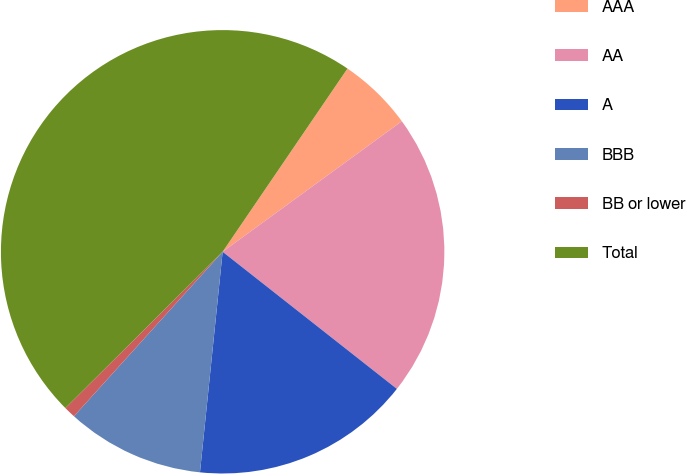Convert chart to OTSL. <chart><loc_0><loc_0><loc_500><loc_500><pie_chart><fcel>AAA<fcel>AA<fcel>A<fcel>BBB<fcel>BB or lower<fcel>Total<nl><fcel>5.46%<fcel>20.63%<fcel>16.02%<fcel>10.07%<fcel>0.85%<fcel>46.97%<nl></chart> 